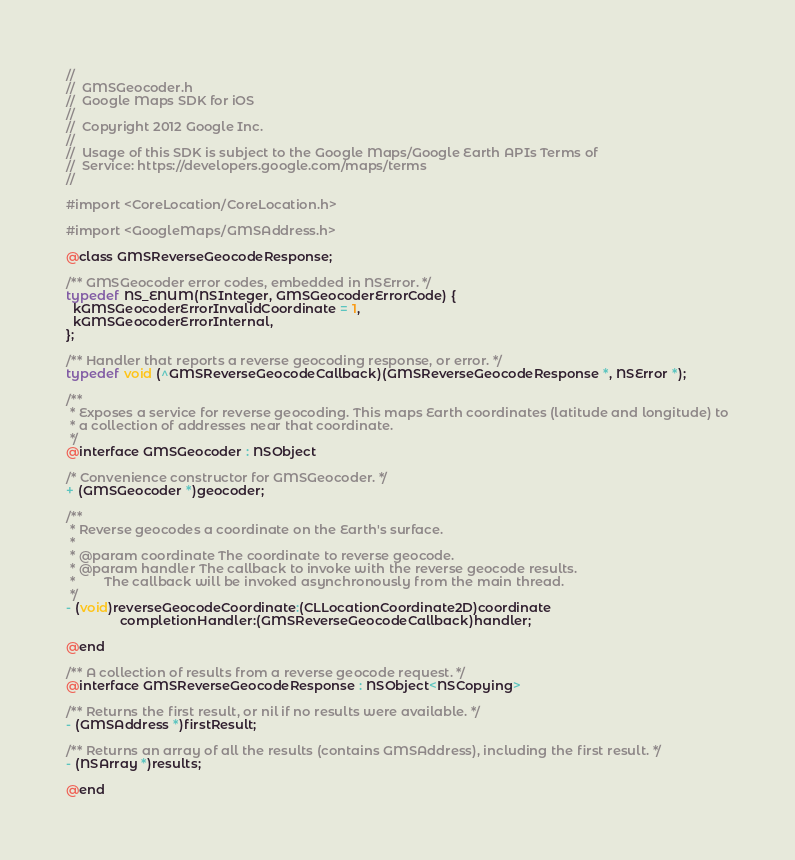Convert code to text. <code><loc_0><loc_0><loc_500><loc_500><_C_>//
//  GMSGeocoder.h
//  Google Maps SDK for iOS
//
//  Copyright 2012 Google Inc.
//
//  Usage of this SDK is subject to the Google Maps/Google Earth APIs Terms of
//  Service: https://developers.google.com/maps/terms
//

#import <CoreLocation/CoreLocation.h>

#import <GoogleMaps/GMSAddress.h>

@class GMSReverseGeocodeResponse;

/** GMSGeocoder error codes, embedded in NSError. */
typedef NS_ENUM(NSInteger, GMSGeocoderErrorCode) {
  kGMSGeocoderErrorInvalidCoordinate = 1,
  kGMSGeocoderErrorInternal,
};

/** Handler that reports a reverse geocoding response, or error. */
typedef void (^GMSReverseGeocodeCallback)(GMSReverseGeocodeResponse *, NSError *);

/**
 * Exposes a service for reverse geocoding. This maps Earth coordinates (latitude and longitude) to
 * a collection of addresses near that coordinate.
 */
@interface GMSGeocoder : NSObject

/* Convenience constructor for GMSGeocoder. */
+ (GMSGeocoder *)geocoder;

/**
 * Reverse geocodes a coordinate on the Earth's surface.
 *
 * @param coordinate The coordinate to reverse geocode.
 * @param handler The callback to invoke with the reverse geocode results.
 *        The callback will be invoked asynchronously from the main thread.
 */
- (void)reverseGeocodeCoordinate:(CLLocationCoordinate2D)coordinate
               completionHandler:(GMSReverseGeocodeCallback)handler;

@end

/** A collection of results from a reverse geocode request. */
@interface GMSReverseGeocodeResponse : NSObject<NSCopying>

/** Returns the first result, or nil if no results were available. */
- (GMSAddress *)firstResult;

/** Returns an array of all the results (contains GMSAddress), including the first result. */
- (NSArray *)results;

@end
</code> 